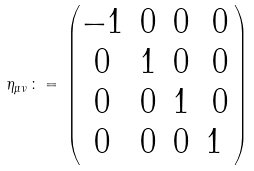<formula> <loc_0><loc_0><loc_500><loc_500>\eta _ { \mu \nu } \, \colon = \, \begin{pmatrix} - 1 & 0 & 0 & 0 \\ 0 & 1 & 0 & 0 \\ 0 & 0 & 1 & 0 \\ 0 & 0 & 0 & 1 \ \end{pmatrix}</formula> 